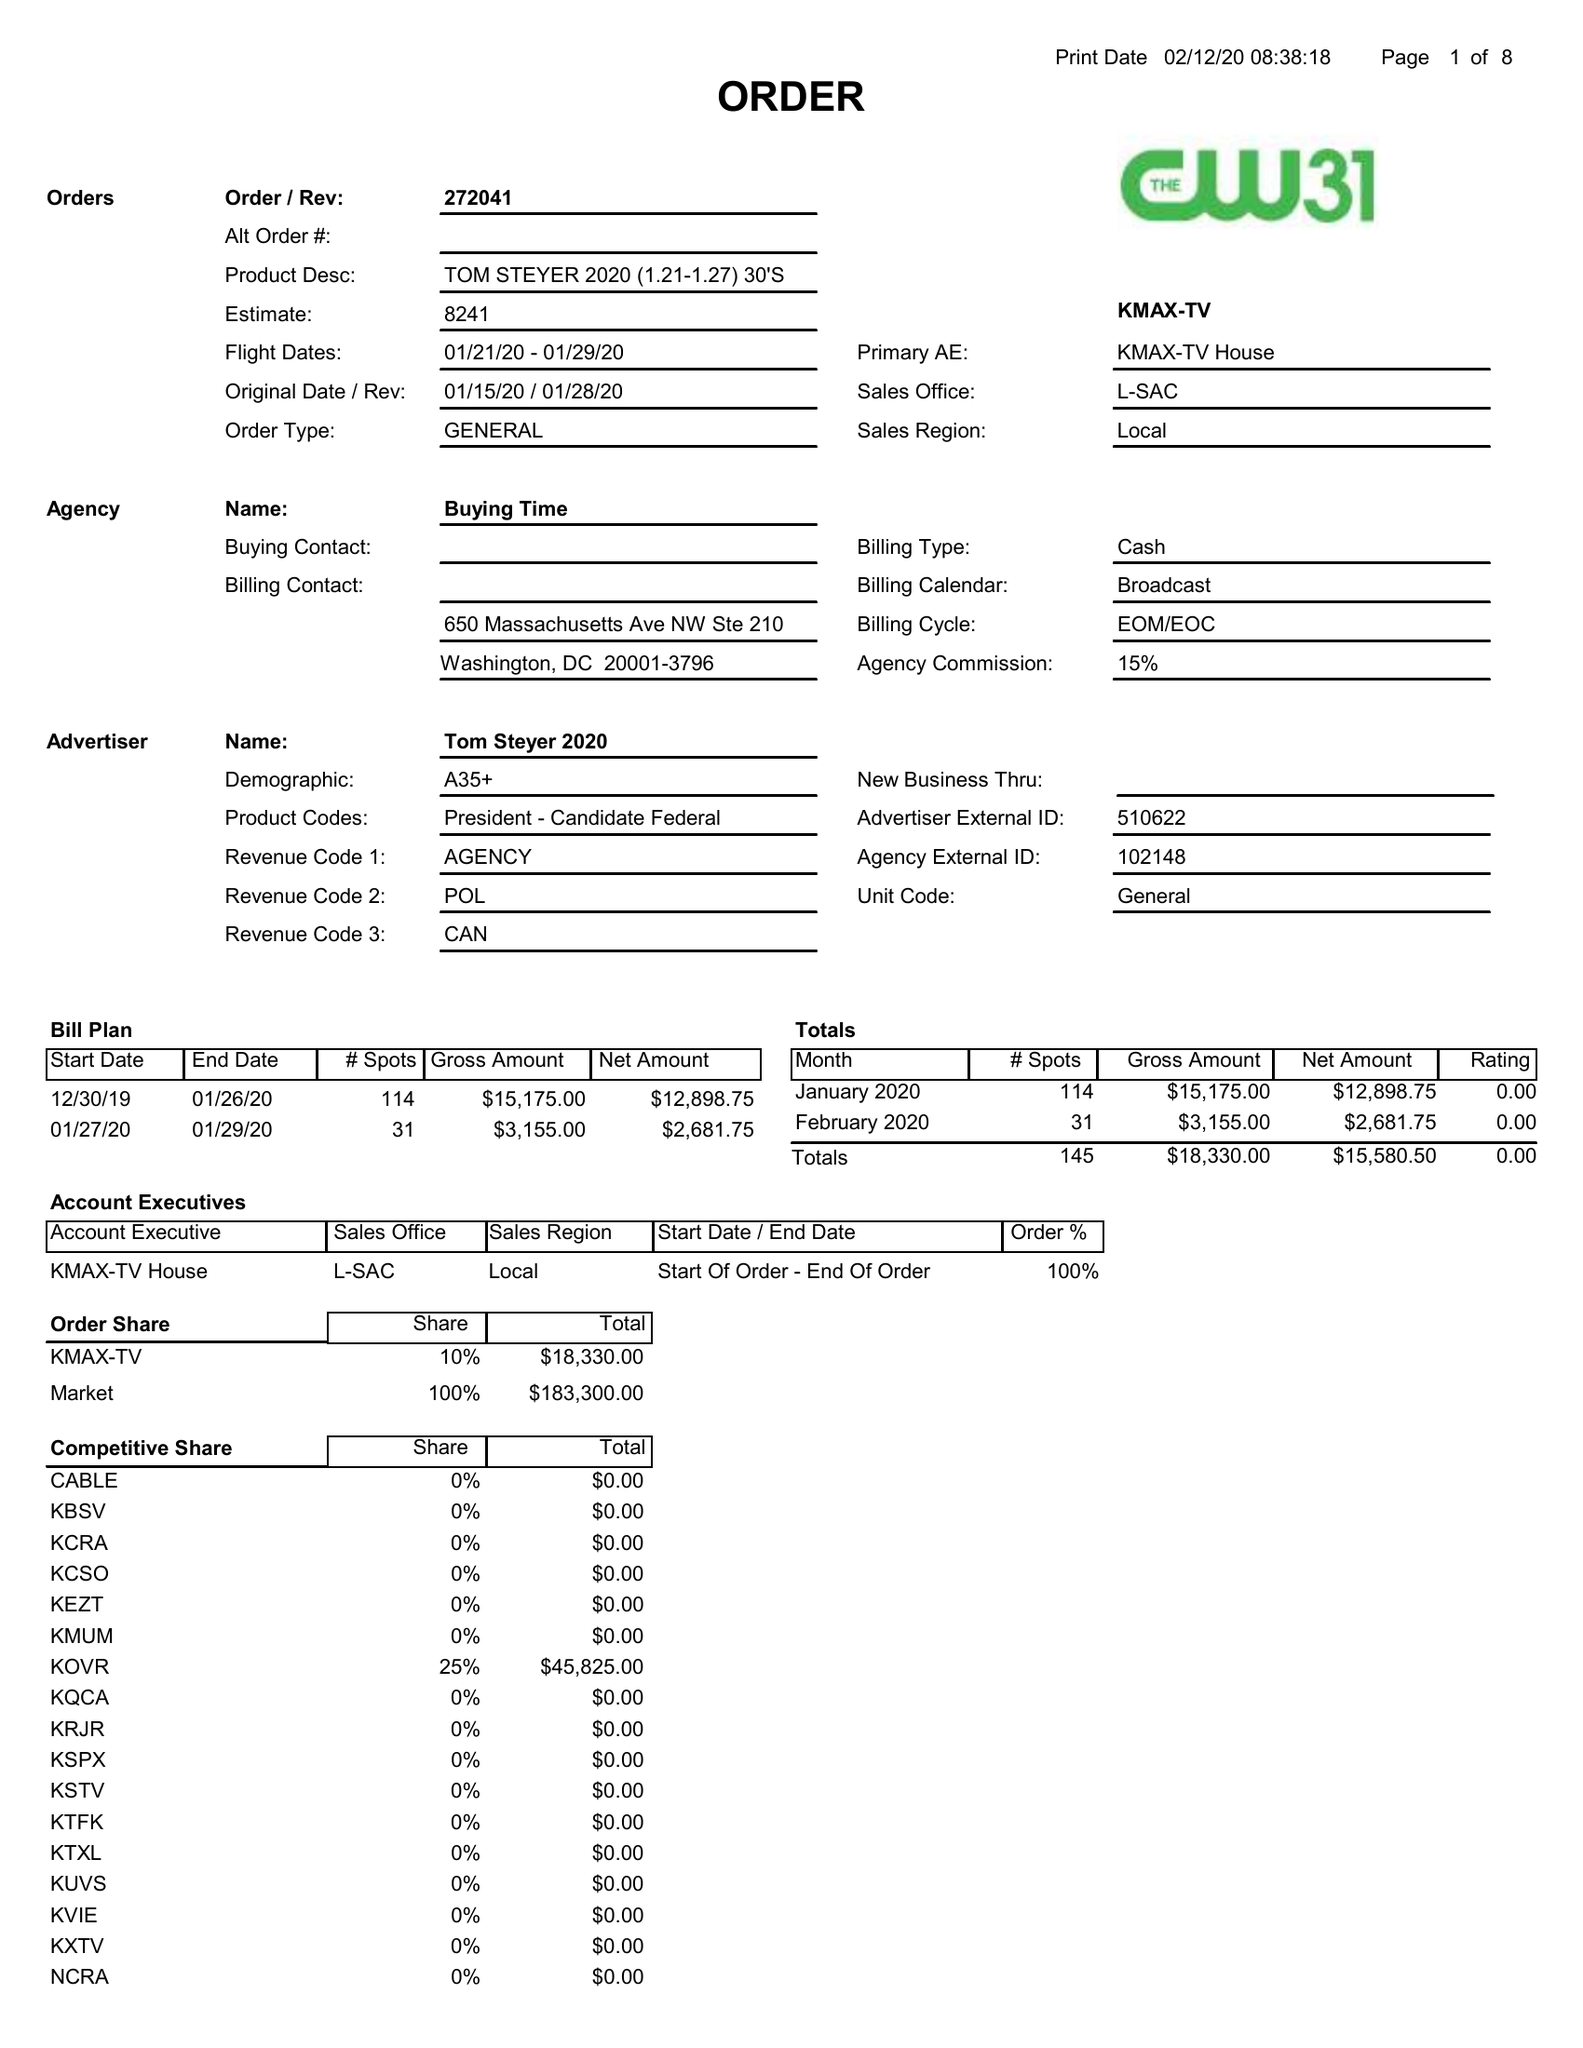What is the value for the contract_num?
Answer the question using a single word or phrase. 272041 